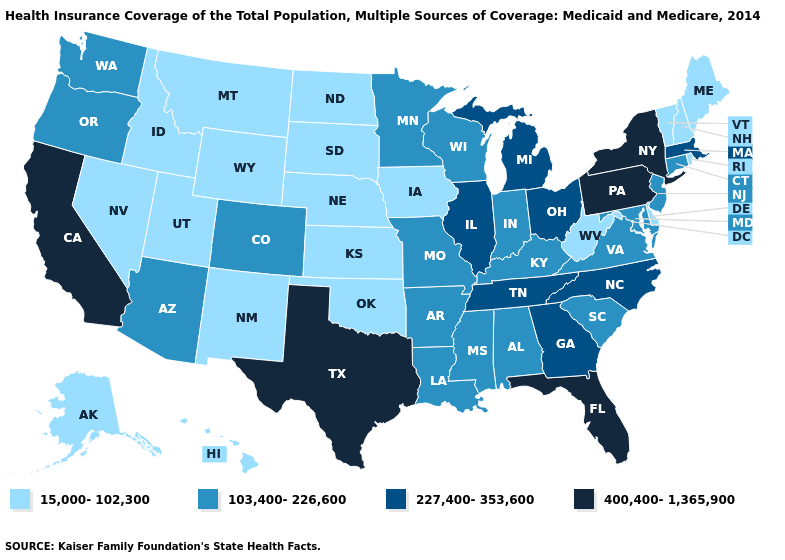What is the highest value in states that border Oregon?
Concise answer only. 400,400-1,365,900. Name the states that have a value in the range 103,400-226,600?
Give a very brief answer. Alabama, Arizona, Arkansas, Colorado, Connecticut, Indiana, Kentucky, Louisiana, Maryland, Minnesota, Mississippi, Missouri, New Jersey, Oregon, South Carolina, Virginia, Washington, Wisconsin. Does South Carolina have the lowest value in the USA?
Answer briefly. No. Name the states that have a value in the range 15,000-102,300?
Give a very brief answer. Alaska, Delaware, Hawaii, Idaho, Iowa, Kansas, Maine, Montana, Nebraska, Nevada, New Hampshire, New Mexico, North Dakota, Oklahoma, Rhode Island, South Dakota, Utah, Vermont, West Virginia, Wyoming. Is the legend a continuous bar?
Keep it brief. No. What is the value of Louisiana?
Give a very brief answer. 103,400-226,600. Does Iowa have the lowest value in the USA?
Give a very brief answer. Yes. Name the states that have a value in the range 227,400-353,600?
Answer briefly. Georgia, Illinois, Massachusetts, Michigan, North Carolina, Ohio, Tennessee. Does California have the highest value in the USA?
Give a very brief answer. Yes. Does Colorado have the lowest value in the USA?
Concise answer only. No. Among the states that border Mississippi , does Tennessee have the lowest value?
Write a very short answer. No. Does the map have missing data?
Short answer required. No. Which states have the lowest value in the West?
Be succinct. Alaska, Hawaii, Idaho, Montana, Nevada, New Mexico, Utah, Wyoming. Does Ohio have the lowest value in the MidWest?
Keep it brief. No. Name the states that have a value in the range 227,400-353,600?
Give a very brief answer. Georgia, Illinois, Massachusetts, Michigan, North Carolina, Ohio, Tennessee. 